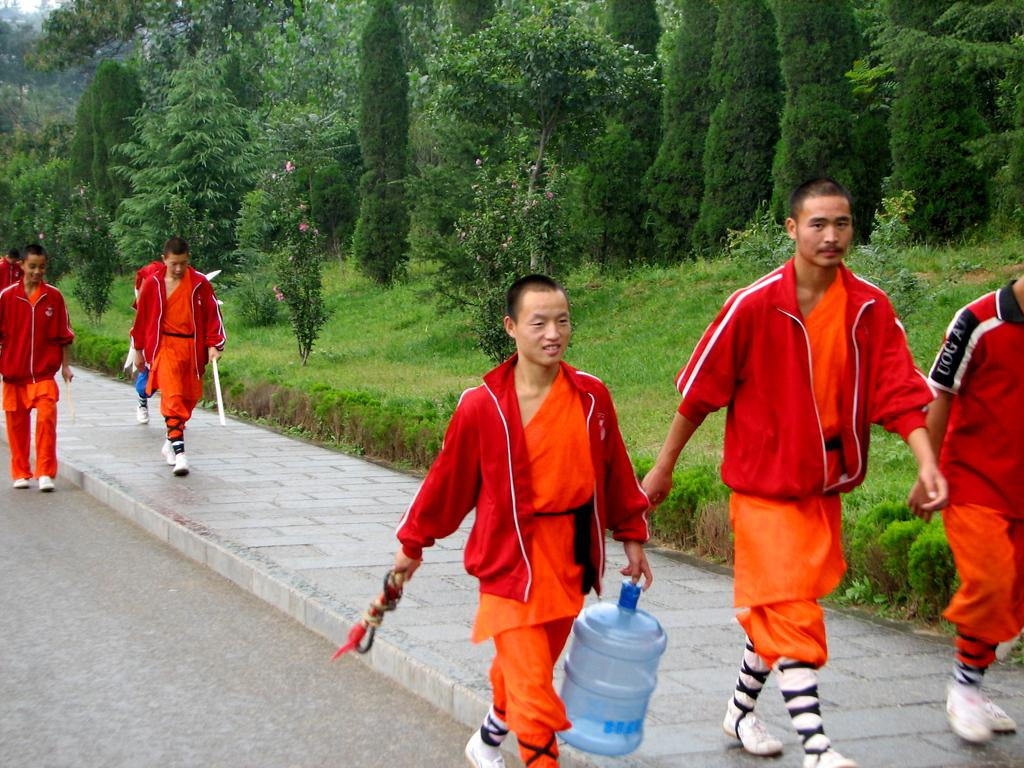What is happening in the image involving a group of people? There is a group of people in the image, and they are walking. Where are the people walking in the image? The people are walking on the road and the footpath. What can be seen in the background of the image? There are trees in the background of the image. What type of liquid can be heard splashing in the image? There is no liquid present in the image, and therefore no splashing sound can be heard. 